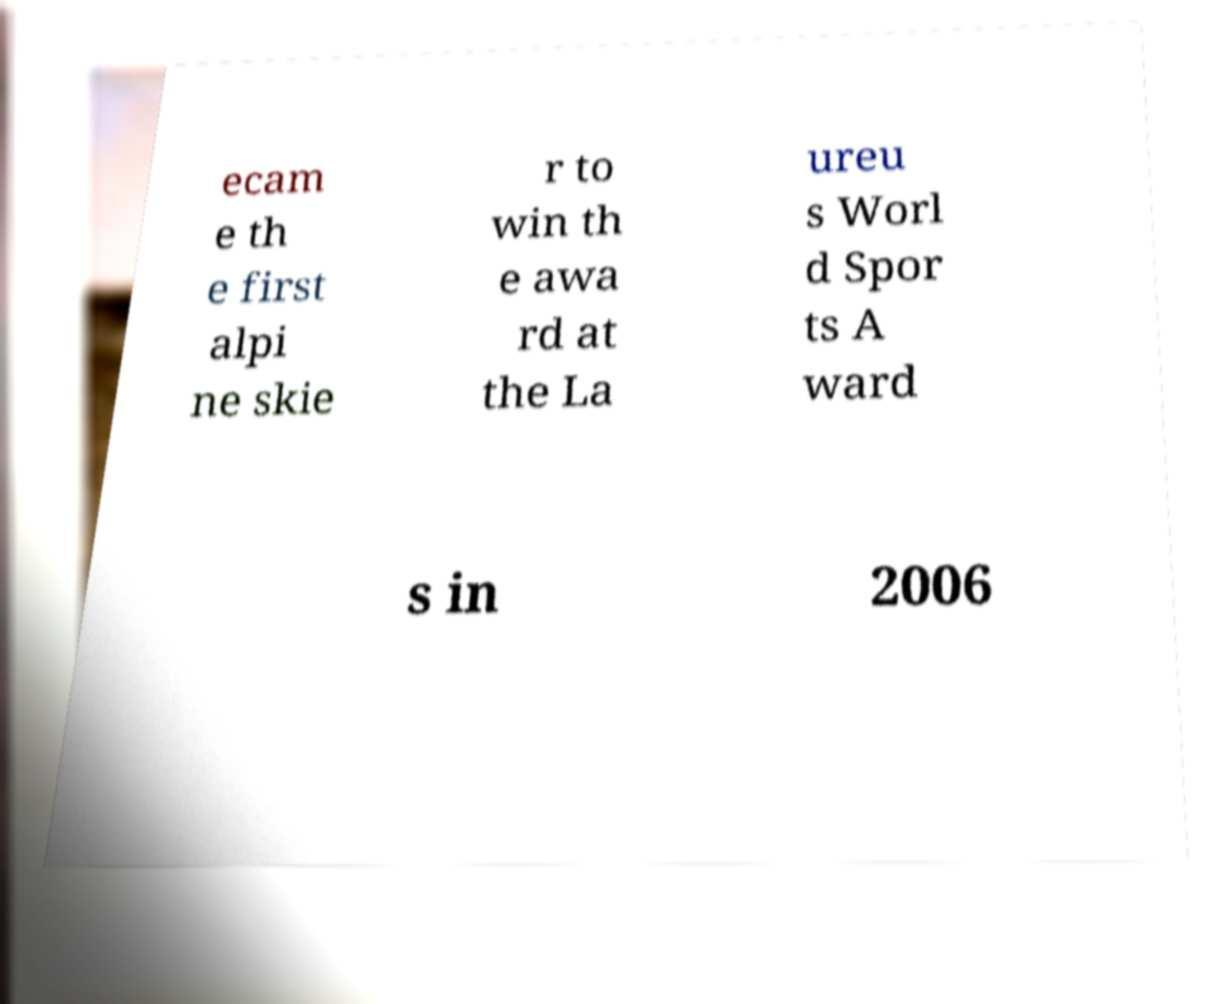There's text embedded in this image that I need extracted. Can you transcribe it verbatim? ecam e th e first alpi ne skie r to win th e awa rd at the La ureu s Worl d Spor ts A ward s in 2006 